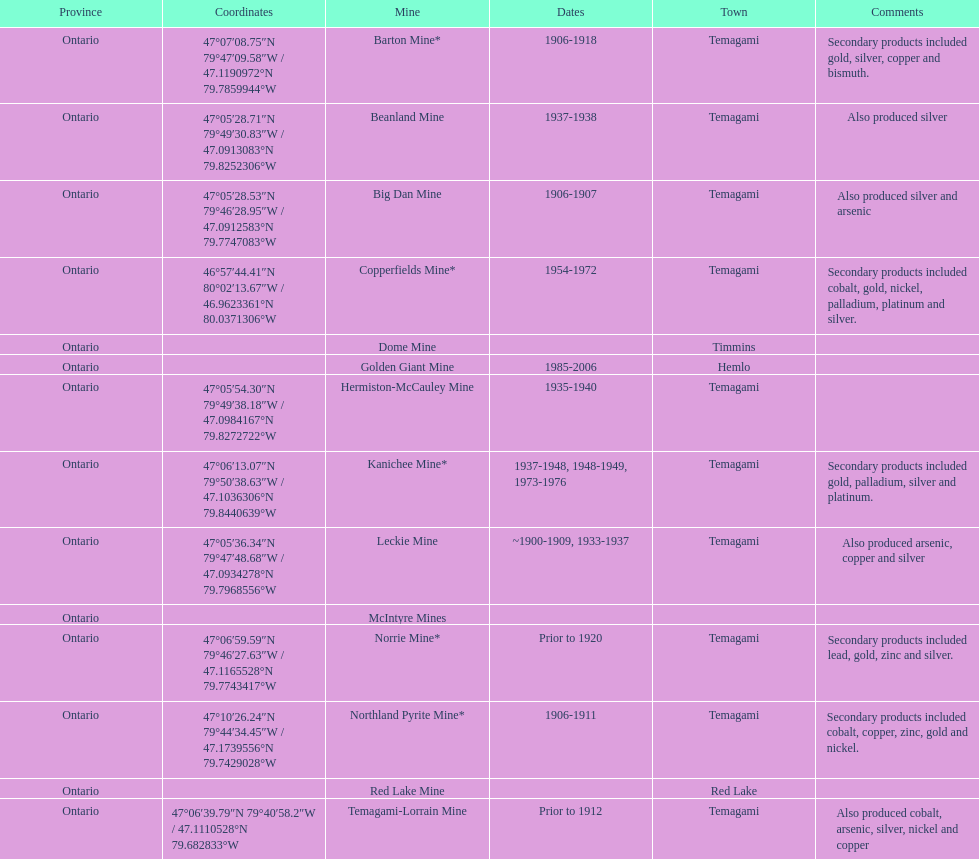What mine is in the town of timmins? Dome Mine. 